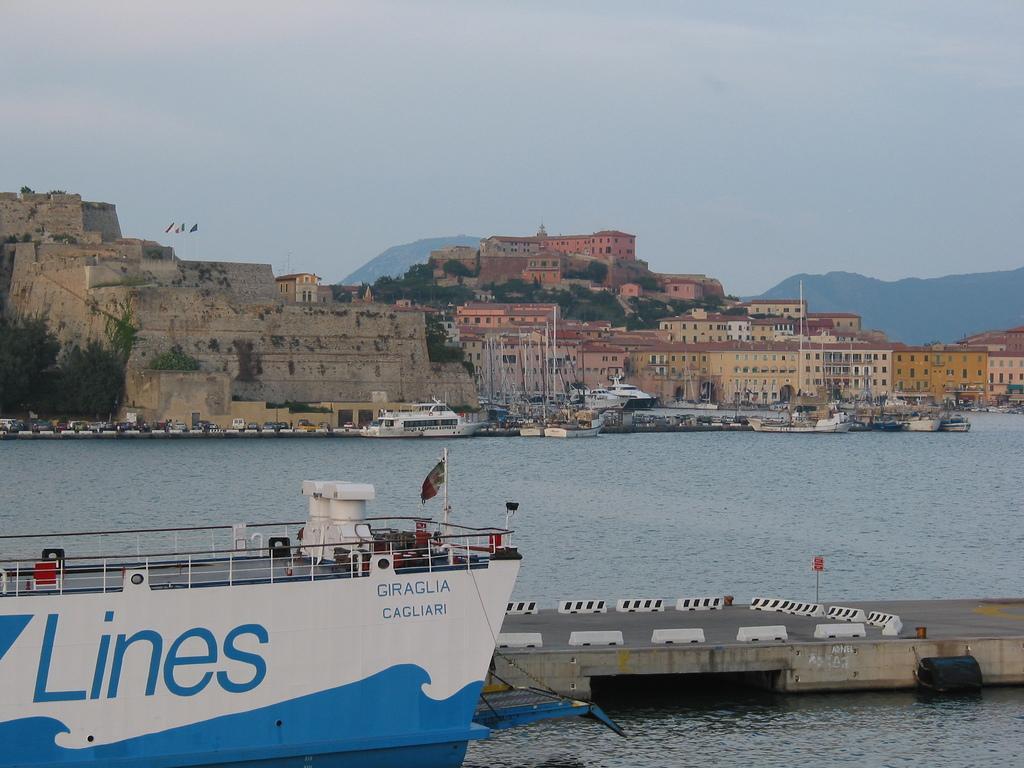Describe this image in one or two sentences. In this picture I can see a ship and few boats in the water and I can see a bridge and few buildings, trees and I can see hills and a cloudy sky and I can see text on the ship. 